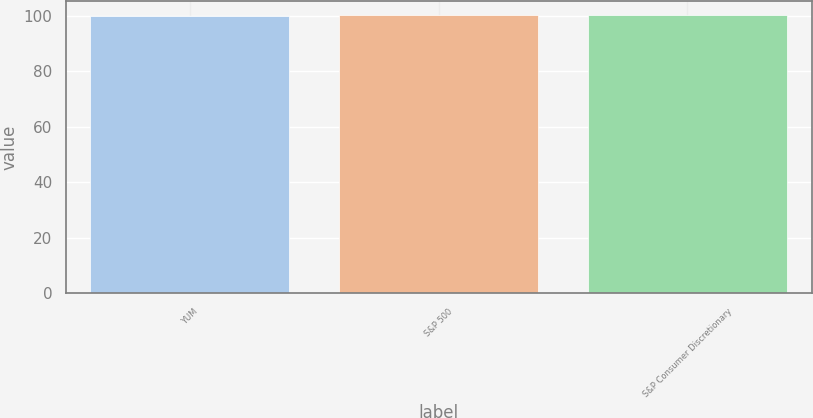<chart> <loc_0><loc_0><loc_500><loc_500><bar_chart><fcel>YUM<fcel>S&P 500<fcel>S&P Consumer Discretionary<nl><fcel>100<fcel>100.1<fcel>100.2<nl></chart> 